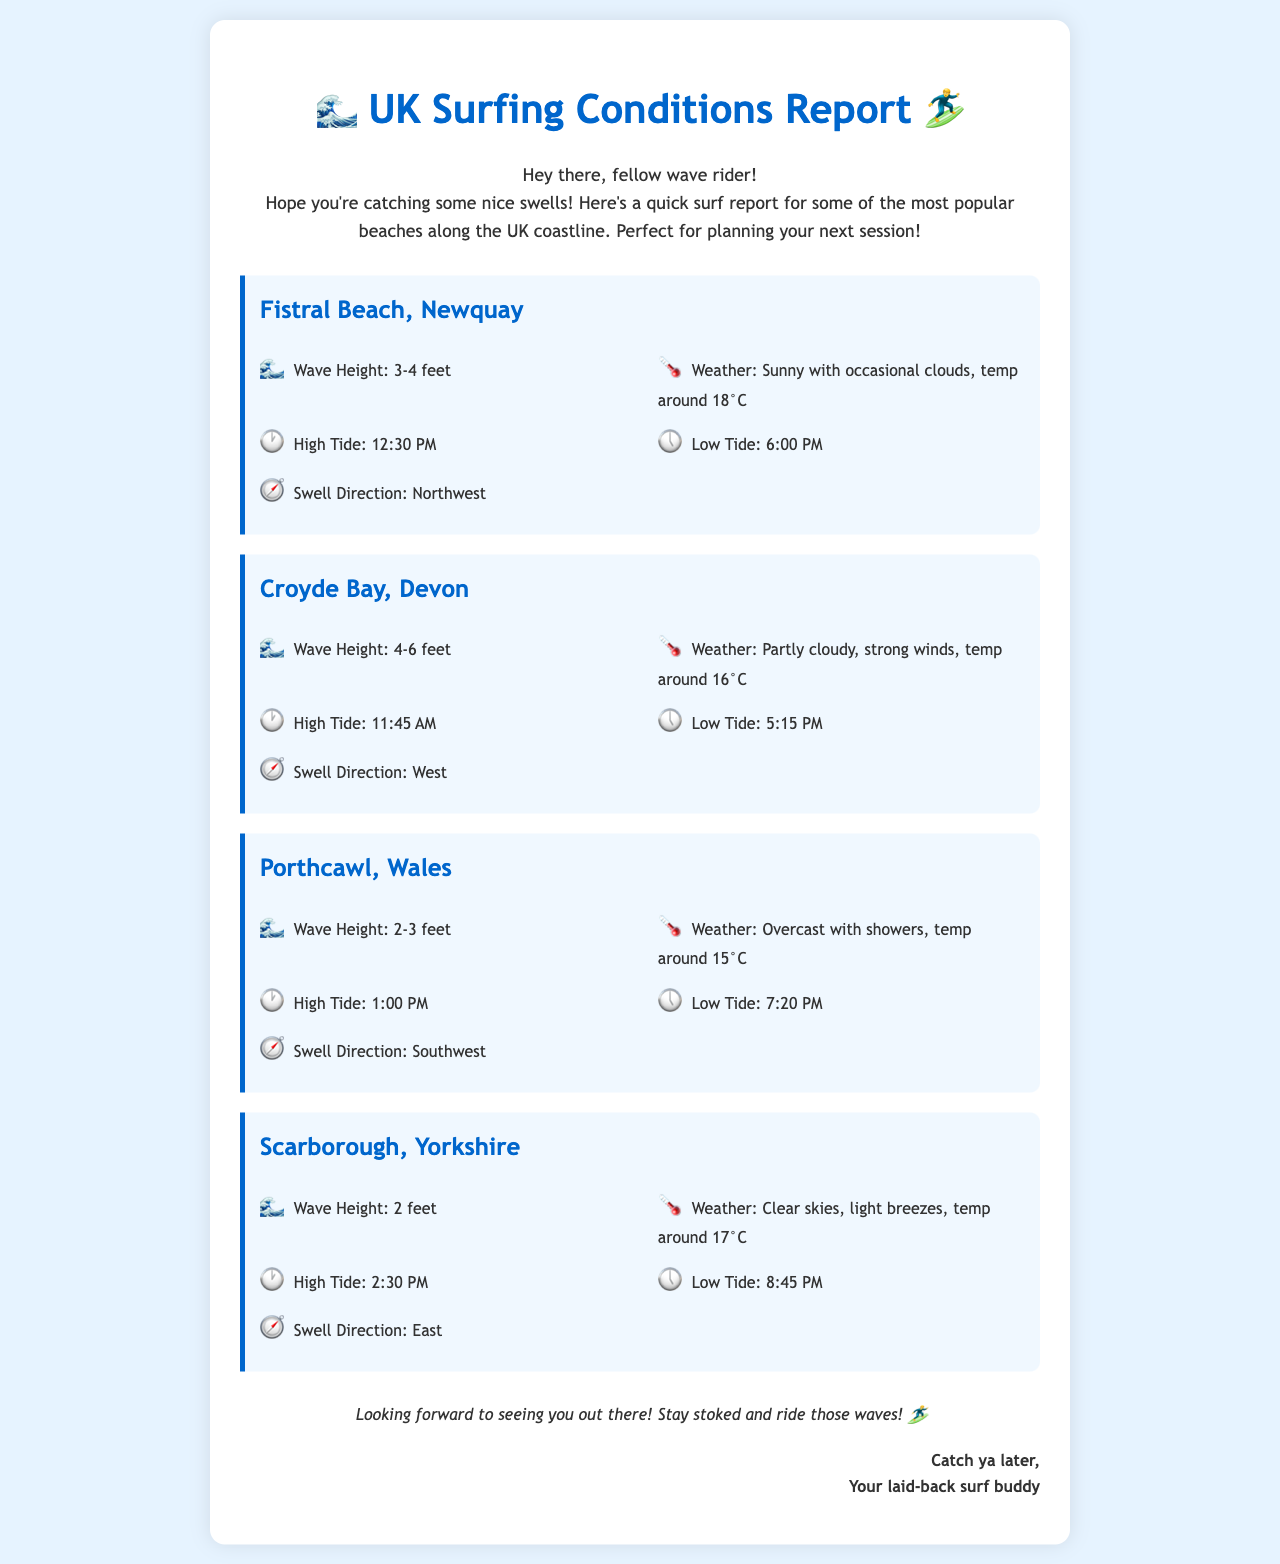What is the wave height at Fistral Beach? The wave height at Fistral Beach is listed in the document as 3-4 feet.
Answer: 3-4 feet What is the weather forecast for Croyde Bay? The weather forecast for Croyde Bay indicates partly cloudy skies, strong winds, and a temperature around 16°C.
Answer: Partly cloudy, strong winds, temp around 16°C What time is high tide at Porthcawl? The document specifies that high tide at Porthcawl is at 1:00 PM.
Answer: 1:00 PM Which beach has the highest wave height? By comparing the wave heights of each beach, it can be determined that Croyde Bay has the highest wave height at 4-6 feet.
Answer: 4-6 feet What is the swell direction for Scarborough? According to the document, the swell direction for Scarborough is to the East.
Answer: East What is the temperature forecast at Fistral Beach? The temperature forecast at Fistral Beach is around 18°C, as stated in the document.
Answer: 18°C Which beach is overcast with showers? The document specifies that Porthcawl is overcast with showers.
Answer: Porthcawl What is the wave height range at Porthcawl? The document notes that the wave height at Porthcawl is between 2-3 feet.
Answer: 2-3 feet What is the closing remark in the email? The closing remark encourages readers to stay stoked and ride those waves, as stated in the document.
Answer: Stay stoked and ride those waves! 